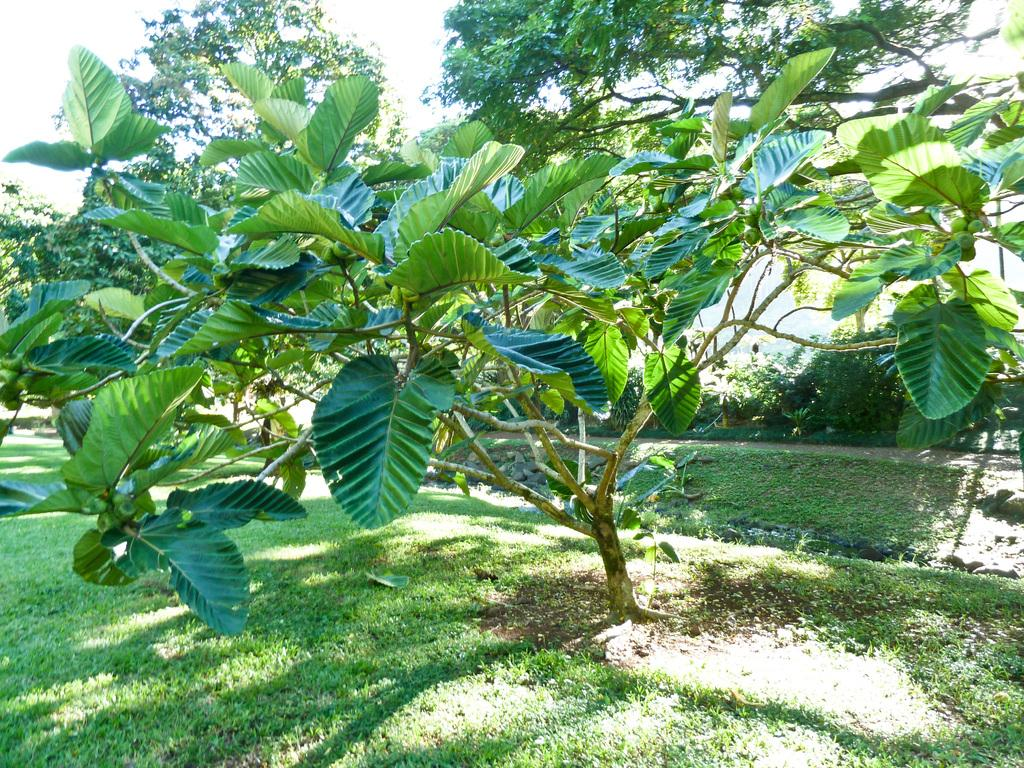What is the main subject in the center of the image? There is a tree in the center of the image. What is the tree standing on? The tree is on the grass. What can be seen in the background of the image? There are trees and plants in the background of the image. What part of the natural environment is visible in the background? The sky is visible in the background of the image. What type of plough is being used to work the land in the image? There is no plough or any indication of work being done on the land in the image. 